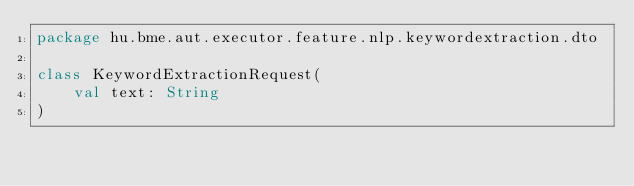<code> <loc_0><loc_0><loc_500><loc_500><_Kotlin_>package hu.bme.aut.executor.feature.nlp.keywordextraction.dto

class KeywordExtractionRequest(
    val text: String
)</code> 